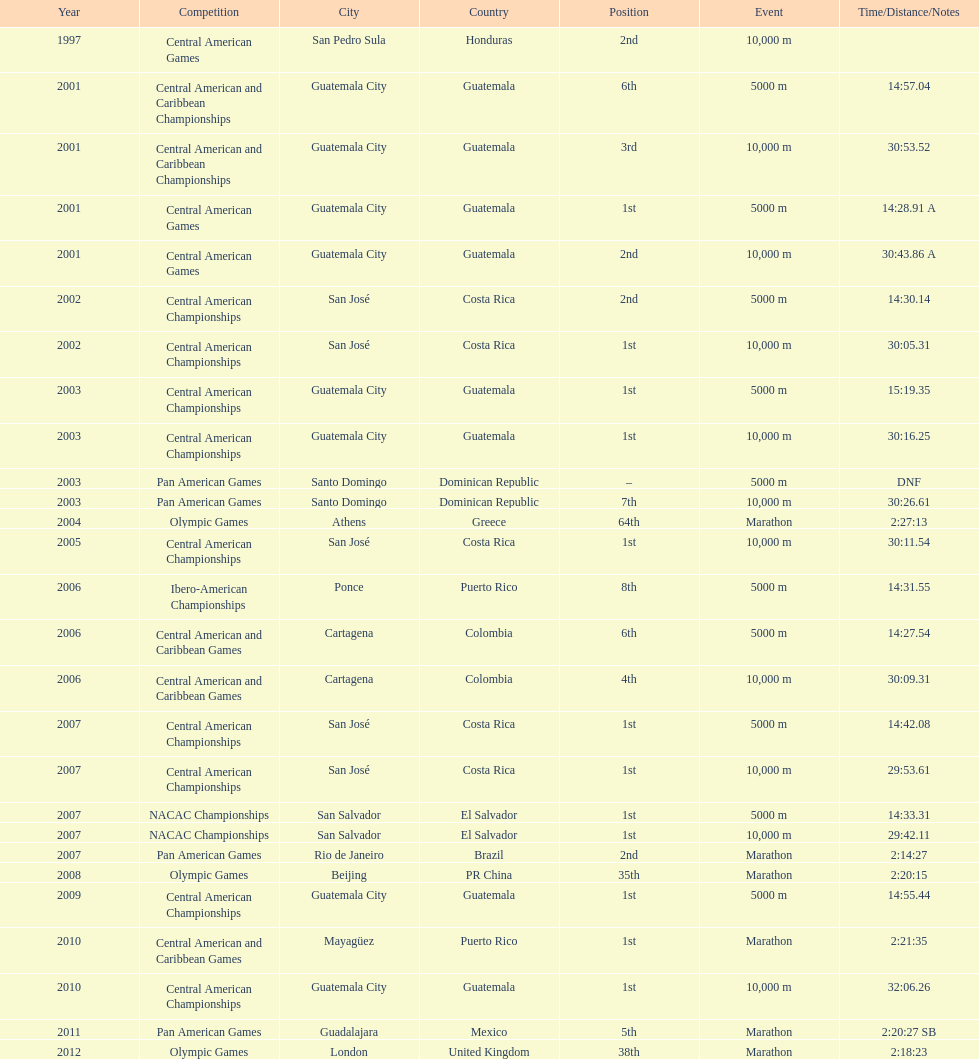Would you mind parsing the complete table? {'header': ['Year', 'Competition', 'City', 'Country', 'Position', 'Event', 'Time/Distance/Notes'], 'rows': [['1997', 'Central American Games', 'San Pedro Sula', 'Honduras', '2nd', '10,000 m', ''], ['2001', 'Central American and Caribbean Championships', 'Guatemala City', 'Guatemala', '6th', '5000 m', '14:57.04'], ['2001', 'Central American and Caribbean Championships', 'Guatemala City', 'Guatemala', '3rd', '10,000 m', '30:53.52'], ['2001', 'Central American Games', 'Guatemala City', 'Guatemala', '1st', '5000 m', '14:28.91 A'], ['2001', 'Central American Games', 'Guatemala City', 'Guatemala', '2nd', '10,000 m', '30:43.86 A'], ['2002', 'Central American Championships', 'San José', 'Costa Rica', '2nd', '5000 m', '14:30.14'], ['2002', 'Central American Championships', 'San José', 'Costa Rica', '1st', '10,000 m', '30:05.31'], ['2003', 'Central American Championships', 'Guatemala City', 'Guatemala', '1st', '5000 m', '15:19.35'], ['2003', 'Central American Championships', 'Guatemala City', 'Guatemala', '1st', '10,000 m', '30:16.25'], ['2003', 'Pan American Games', 'Santo Domingo', 'Dominican Republic', '–', '5000 m', 'DNF'], ['2003', 'Pan American Games', 'Santo Domingo', 'Dominican Republic', '7th', '10,000 m', '30:26.61'], ['2004', 'Olympic Games', 'Athens', 'Greece', '64th', 'Marathon', '2:27:13'], ['2005', 'Central American Championships', 'San José', 'Costa Rica', '1st', '10,000 m', '30:11.54'], ['2006', 'Ibero-American Championships', 'Ponce', 'Puerto Rico', '8th', '5000 m', '14:31.55'], ['2006', 'Central American and Caribbean Games', 'Cartagena', 'Colombia', '6th', '5000 m', '14:27.54'], ['2006', 'Central American and Caribbean Games', 'Cartagena', 'Colombia', '4th', '10,000 m', '30:09.31'], ['2007', 'Central American Championships', 'San José', 'Costa Rica', '1st', '5000 m', '14:42.08'], ['2007', 'Central American Championships', 'San José', 'Costa Rica', '1st', '10,000 m', '29:53.61'], ['2007', 'NACAC Championships', 'San Salvador', 'El Salvador', '1st', '5000 m', '14:33.31'], ['2007', 'NACAC Championships', 'San Salvador', 'El Salvador', '1st', '10,000 m', '29:42.11'], ['2007', 'Pan American Games', 'Rio de Janeiro', 'Brazil', '2nd', 'Marathon', '2:14:27'], ['2008', 'Olympic Games', 'Beijing', 'PR China', '35th', 'Marathon', '2:20:15'], ['2009', 'Central American Championships', 'Guatemala City', 'Guatemala', '1st', '5000 m', '14:55.44'], ['2010', 'Central American and Caribbean Games', 'Mayagüez', 'Puerto Rico', '1st', 'Marathon', '2:21:35'], ['2010', 'Central American Championships', 'Guatemala City', 'Guatemala', '1st', '10,000 m', '32:06.26'], ['2011', 'Pan American Games', 'Guadalajara', 'Mexico', '5th', 'Marathon', '2:20:27 SB'], ['2012', 'Olympic Games', 'London', 'United Kingdom', '38th', 'Marathon', '2:18:23']]} Which event is listed more between the 10,000m and the 5000m? 10,000 m. 